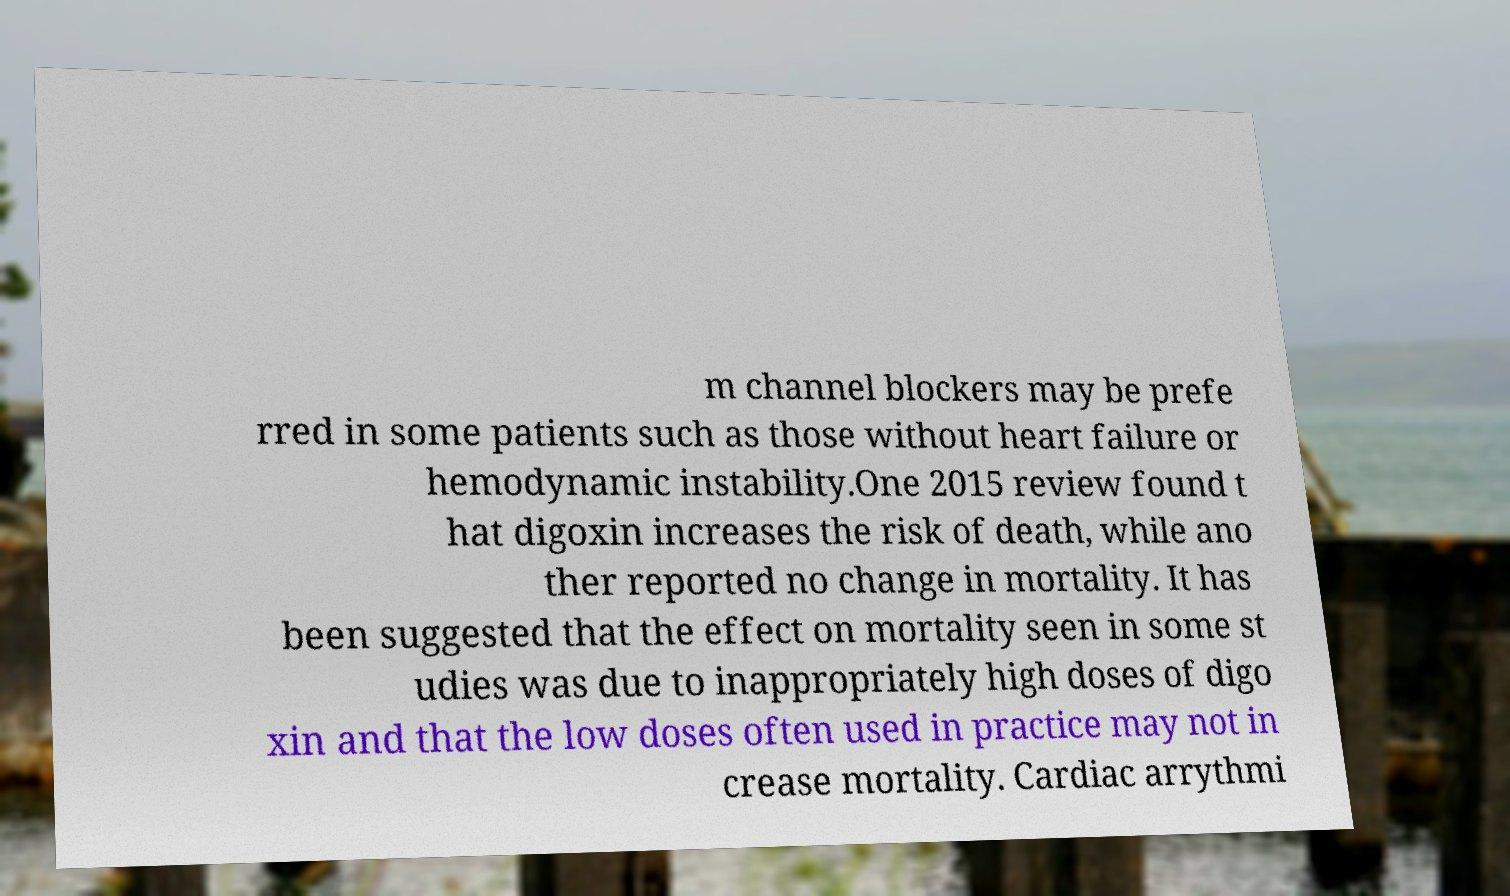Could you assist in decoding the text presented in this image and type it out clearly? m channel blockers may be prefe rred in some patients such as those without heart failure or hemodynamic instability.One 2015 review found t hat digoxin increases the risk of death, while ano ther reported no change in mortality. It has been suggested that the effect on mortality seen in some st udies was due to inappropriately high doses of digo xin and that the low doses often used in practice may not in crease mortality. Cardiac arrythmi 